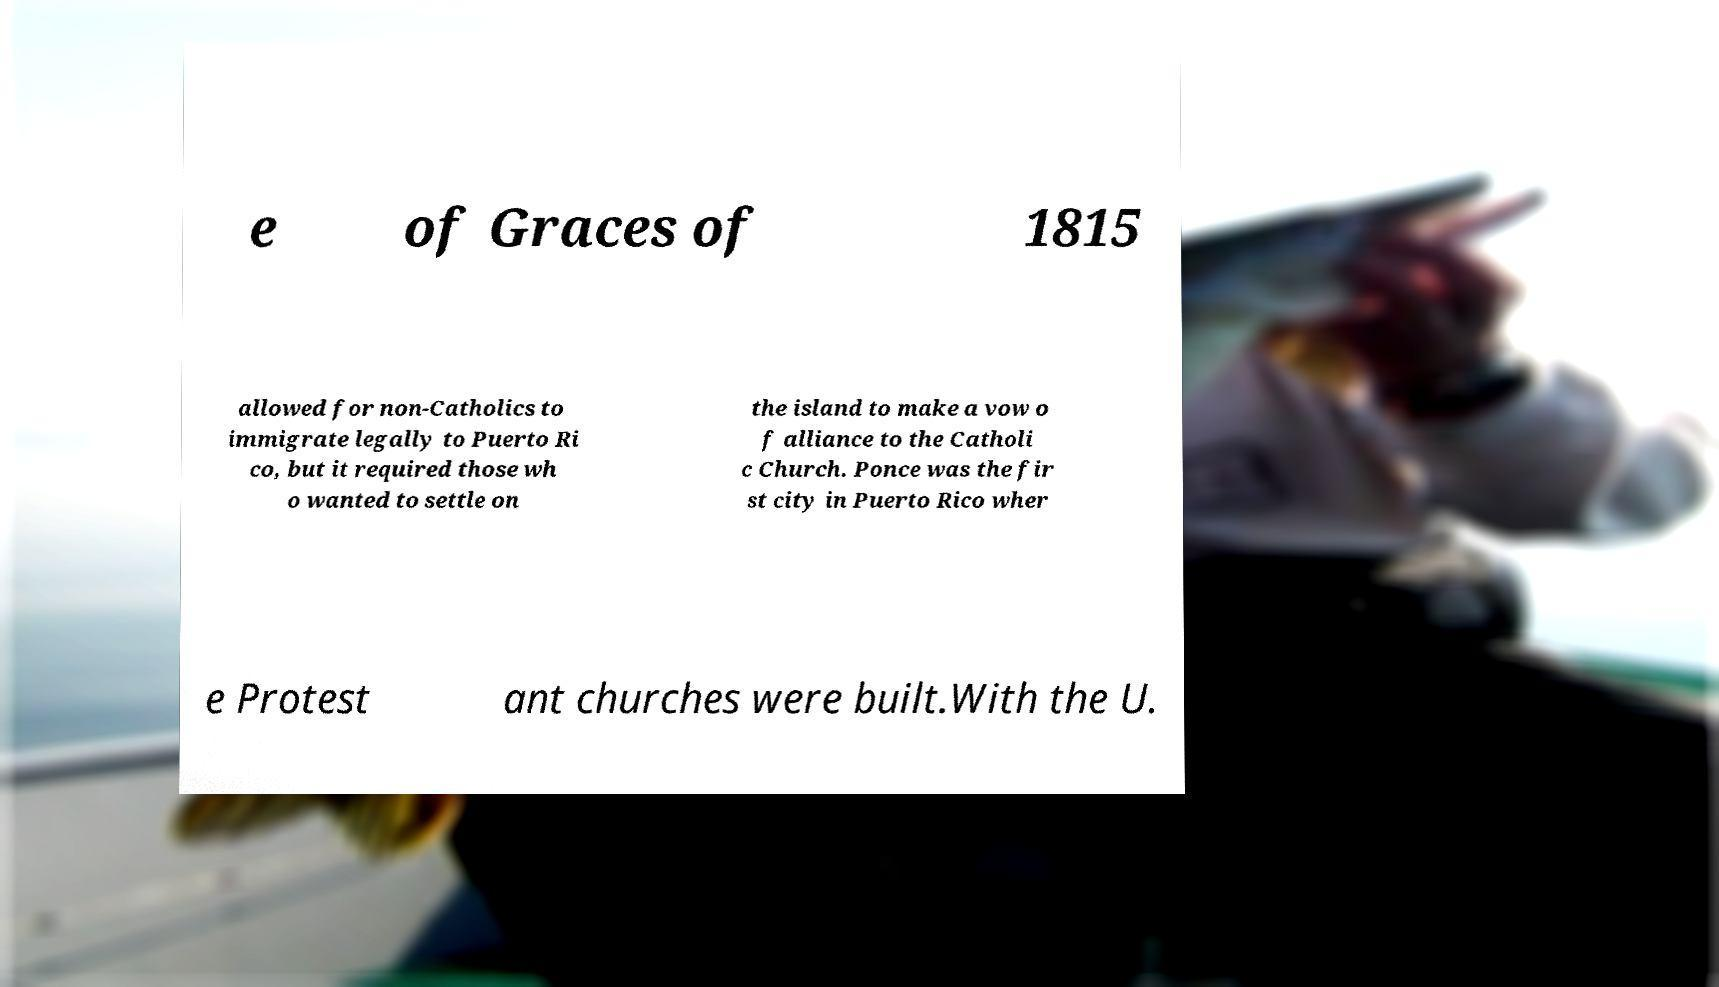What messages or text are displayed in this image? I need them in a readable, typed format. e of Graces of 1815 allowed for non-Catholics to immigrate legally to Puerto Ri co, but it required those wh o wanted to settle on the island to make a vow o f alliance to the Catholi c Church. Ponce was the fir st city in Puerto Rico wher e Protest ant churches were built.With the U. 